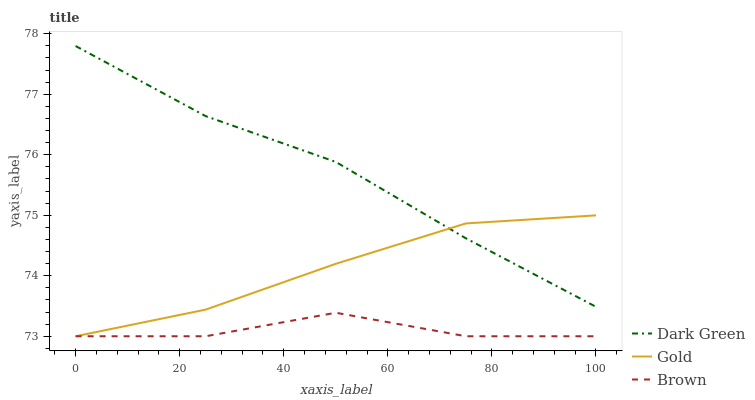Does Brown have the minimum area under the curve?
Answer yes or no. Yes. Does Dark Green have the maximum area under the curve?
Answer yes or no. Yes. Does Gold have the minimum area under the curve?
Answer yes or no. No. Does Gold have the maximum area under the curve?
Answer yes or no. No. Is Gold the smoothest?
Answer yes or no. Yes. Is Brown the roughest?
Answer yes or no. Yes. Is Dark Green the smoothest?
Answer yes or no. No. Is Dark Green the roughest?
Answer yes or no. No. Does Brown have the lowest value?
Answer yes or no. Yes. Does Dark Green have the lowest value?
Answer yes or no. No. Does Dark Green have the highest value?
Answer yes or no. Yes. Does Gold have the highest value?
Answer yes or no. No. Is Brown less than Dark Green?
Answer yes or no. Yes. Is Dark Green greater than Brown?
Answer yes or no. Yes. Does Gold intersect Dark Green?
Answer yes or no. Yes. Is Gold less than Dark Green?
Answer yes or no. No. Is Gold greater than Dark Green?
Answer yes or no. No. Does Brown intersect Dark Green?
Answer yes or no. No. 